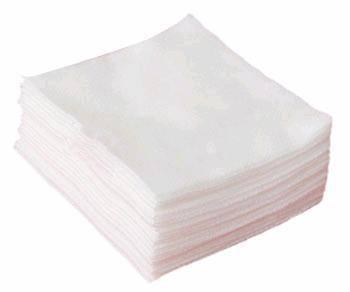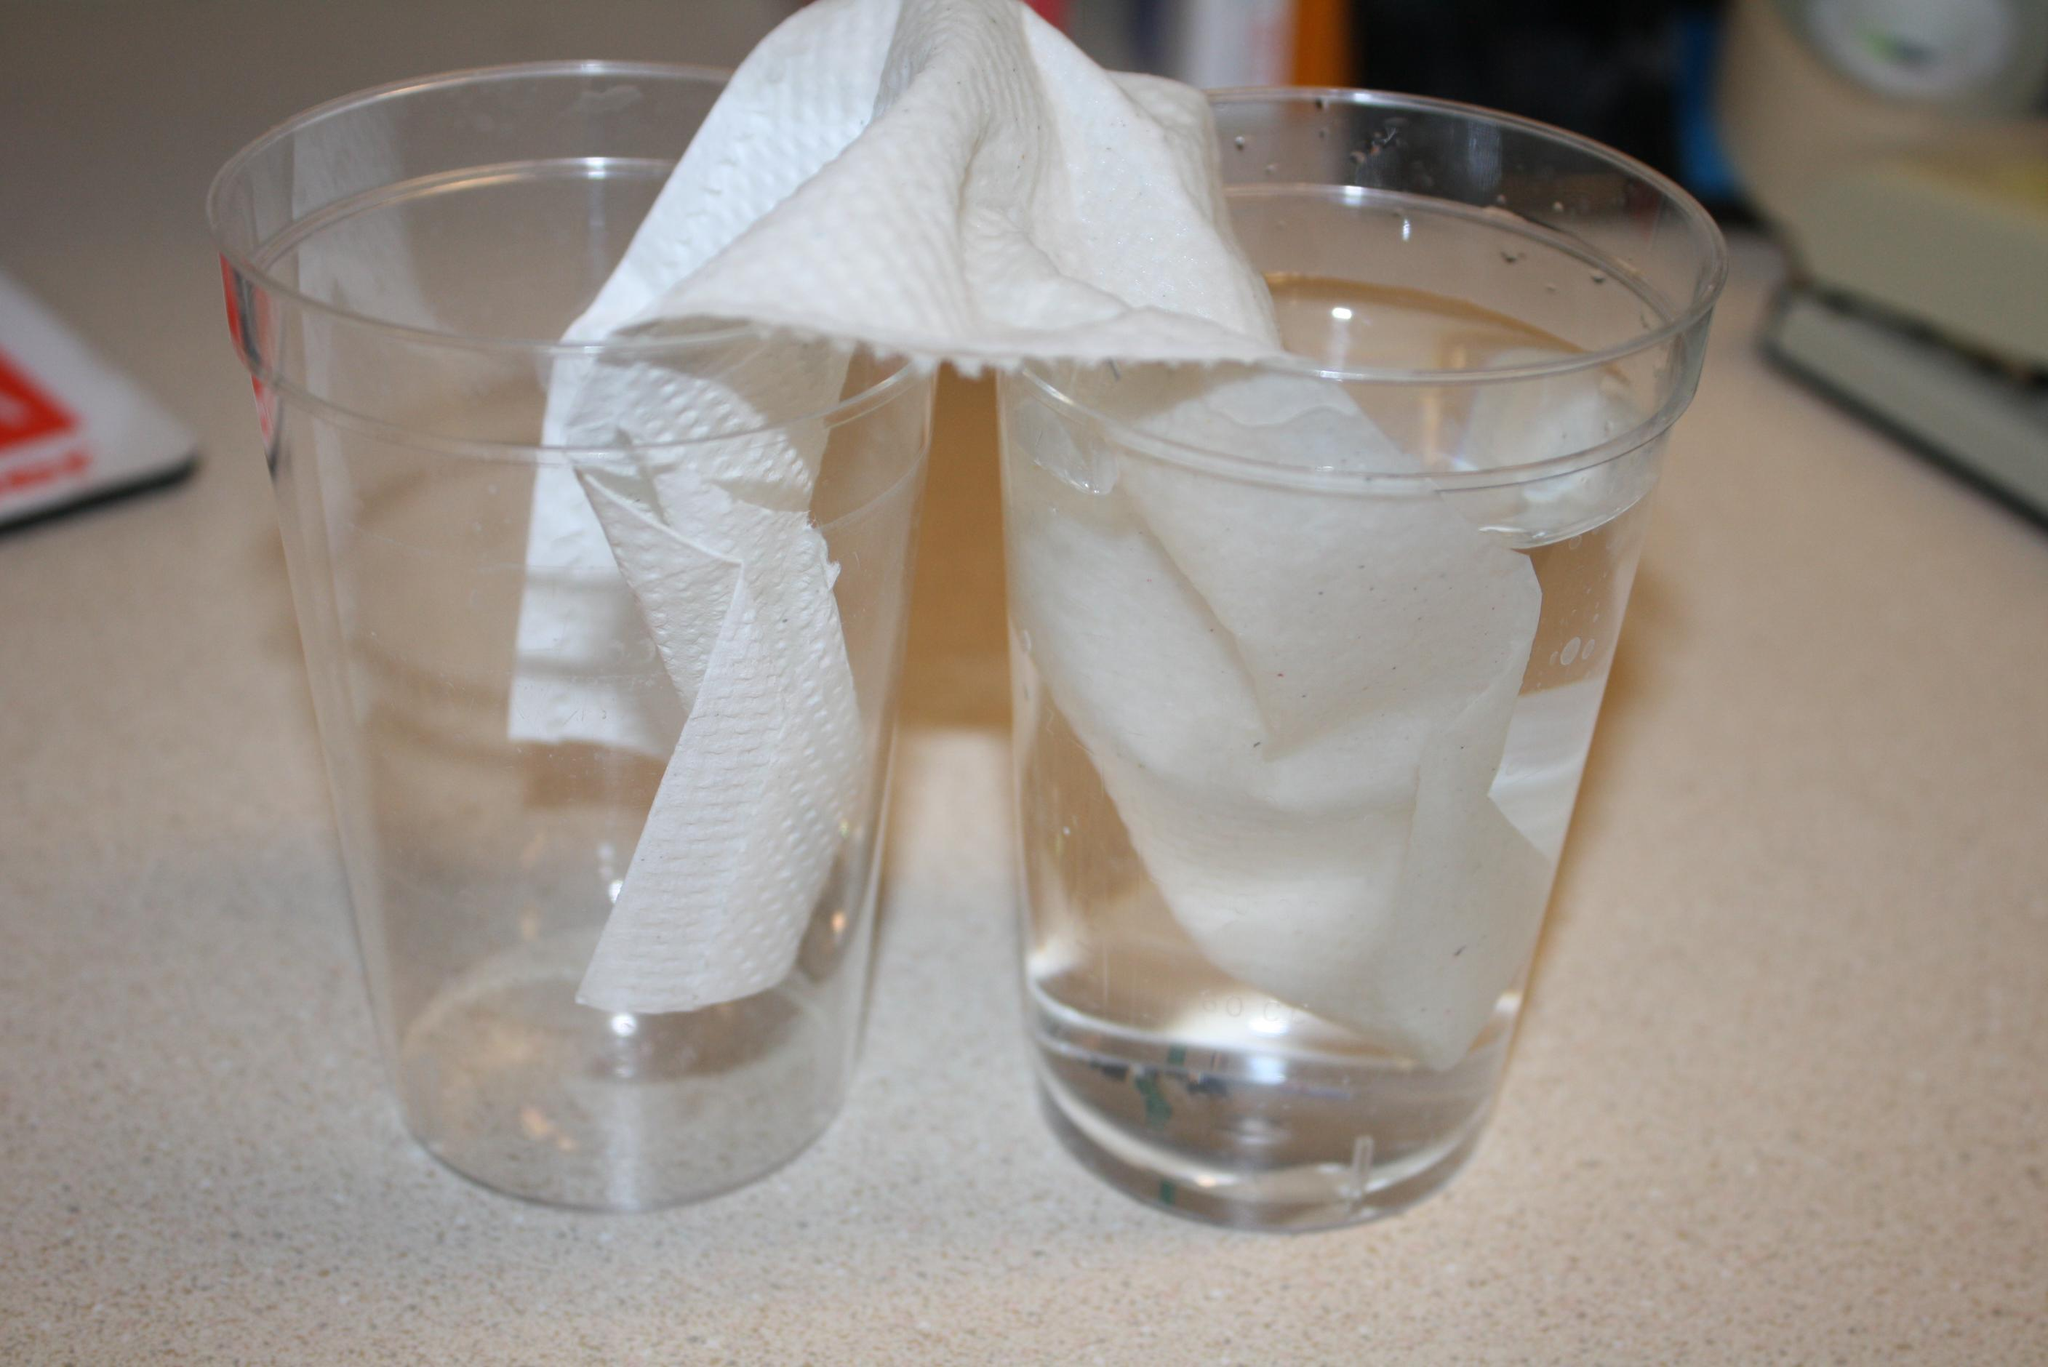The first image is the image on the left, the second image is the image on the right. For the images shown, is this caption "A paper towel is soaking in liquid in at least to glasses." true? Answer yes or no. Yes. The first image is the image on the left, the second image is the image on the right. Given the left and right images, does the statement "One image shows a paper towel dipped in at least one colored liquid, and the other image includes a glass of clear liquid and a paper towel." hold true? Answer yes or no. No. 